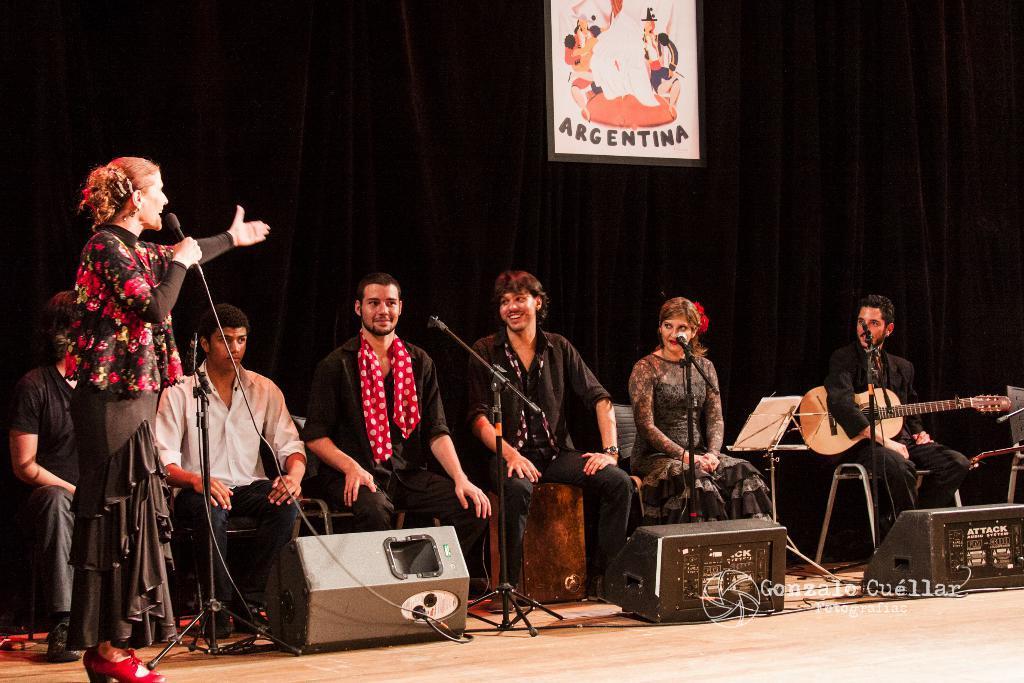Please provide a concise description of this image. There are group of persons on the stage, all of them are wearing black except him. A woman is standing and she is wearing a jacket, a black skirt and a red heels. She is holding a mike. These three people are staring at her. One person is holding a guitar. There are three sound speakers in front of them and one frame, curtain behind them. 